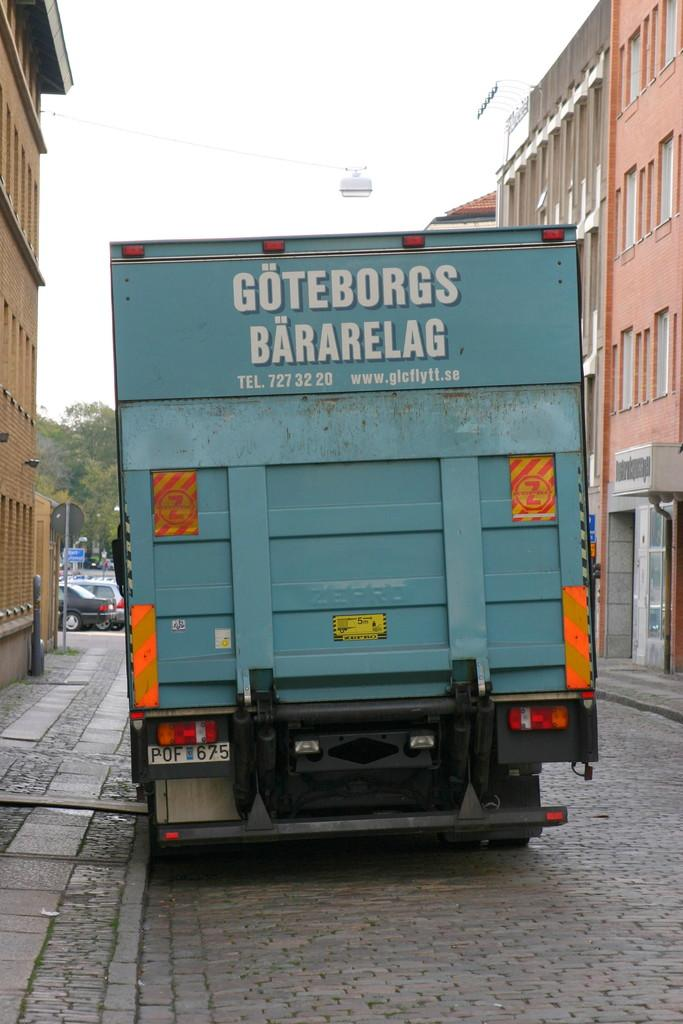What is the main feature of the image? There is a road in the image. What can be seen on the road? There is a truck on the road. What is written on the truck? Something is written on the truck. What type of structures are located near the road? There are buildings with windows on the sides of the road. What can be seen in the background of the image? There are trees, vehicles, and the sky visible in the background of the image. What type of screw can be seen in the image? There is no screw present in the image. What type of thunder can be heard in the image? There is no sound, including thunder, present in the image, as it is a still photograph. 